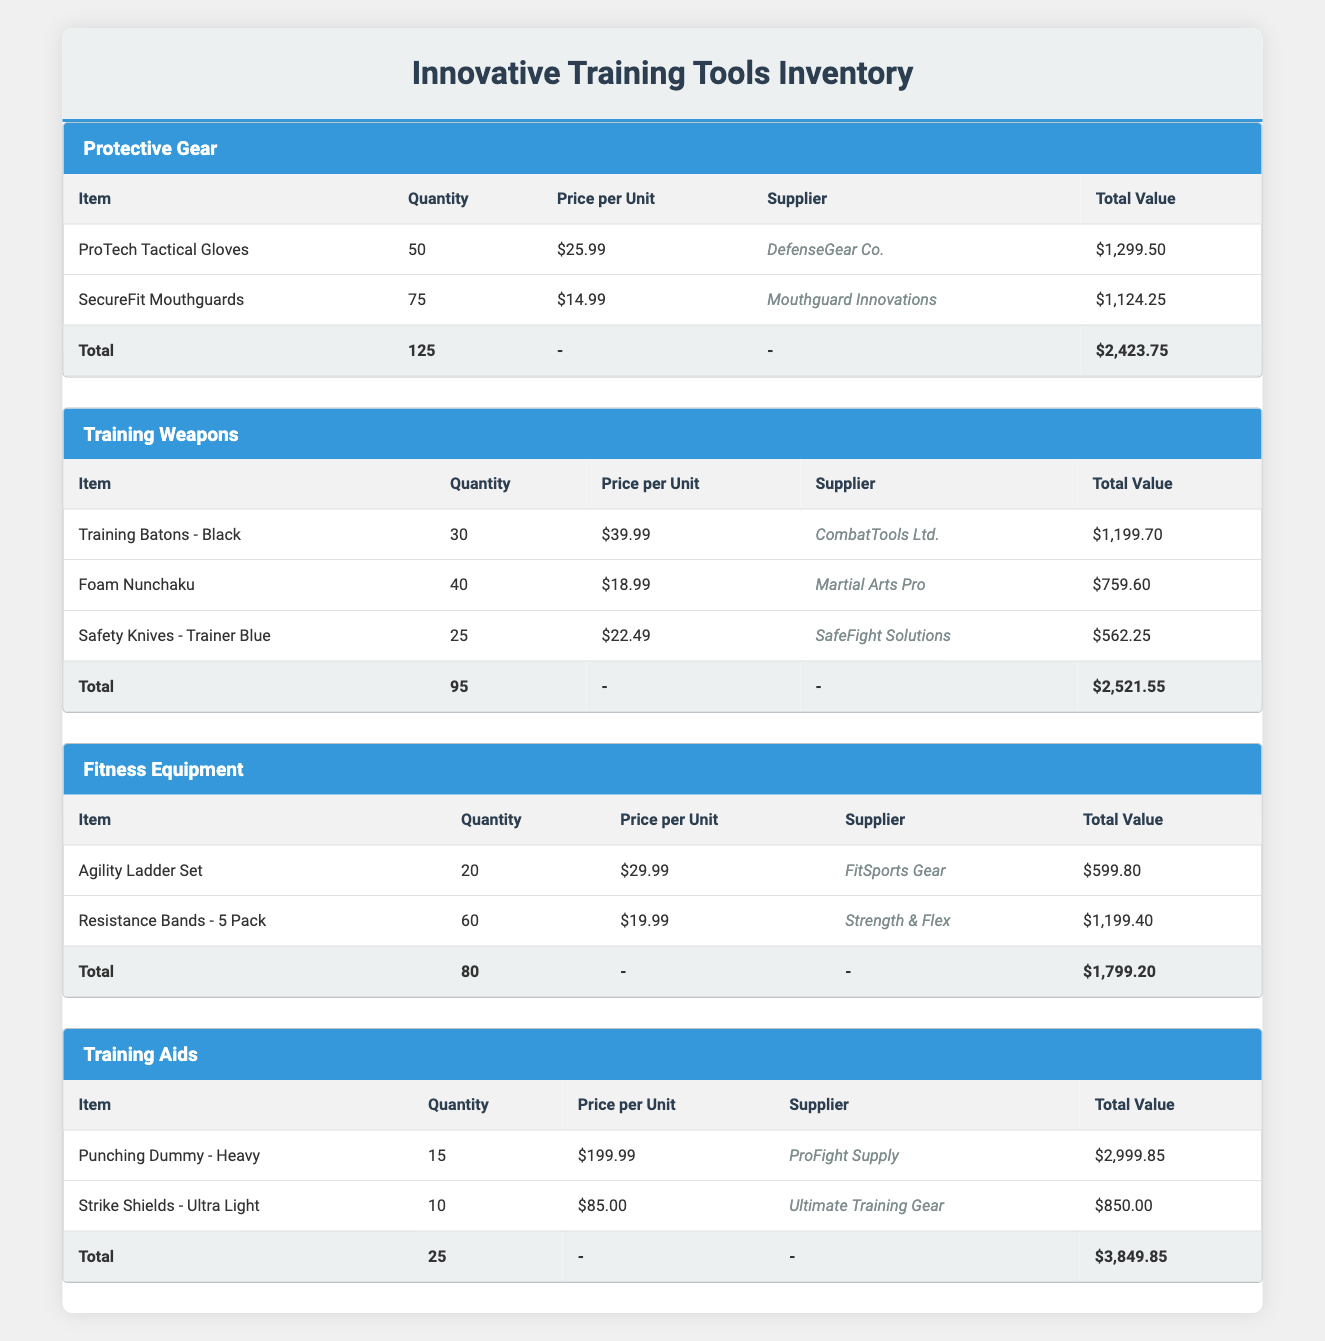What is the total quantity of items in the Protective Gear category? In the Protective Gear category, there are 50 ProTech Tactical Gloves and 75 SecureFit Mouthguards. Adding these together gives us a total quantity of 50 + 75 = 125.
Answer: 125 Which supplier provides the Foam Nunchaku? The Foam Nunchaku is listed under the Training Weapons category, and the supplier for this item is Martial Arts Pro.
Answer: Martial Arts Pro What is the total value of items in the Fitness Equipment category? In the Fitness Equipment category, the Agility Ladder Set is valued at $599.80 and the Resistance Bands - 5 Pack at $1,199.40. Adding these gives us a total of $599.80 + $1,199.40 = $1,799.20.
Answer: $1,799.20 Is the total quantity of Training Weapons greater than that of Fitness Equipment? The total quantity of items in the Training Weapons category is 95 (30 + 40 + 25) and for Fitness Equipment is 80 (20 + 60). Since 95 is greater than 80, the statement is true.
Answer: Yes What is the average price per unit for items in the Training Aids category? The Punching Dummy - Heavy costs $199.99 and the Strike Shields - Ultra Light costs $85.00. To find the average, we first sum the prices: $199.99 + $85.00 = $284.99. Then we divide by the number of items, which is 2, so the average is $284.99 / 2 = $142.495, rounded to $142.50.
Answer: $142.50 How many more SecureFit Mouthguards are there than ProTech Tactical Gloves? The quantity of SecureFit Mouthguards is 75 and the quantity of ProTech Tactical Gloves is 50. The difference is 75 - 50 = 25, meaning there are 25 more Mouthguards.
Answer: 25 What is the total value of Training Aids items combined? The total value of items in the Training Aids category is calculated by adding the values of the Punching Dummy - Heavy at $2,999.85 and the Strike Shields - Ultra Light at $850.00. Thus, $2,999.85 + $850.00 = $3,849.85.
Answer: $3,849.85 Does the supplier DefenseGear Co. provide any items in the Fitness Equipment category? Based on the data, DefenseGear Co. supplies the ProTech Tactical Gloves in the Protective Gear category. There are no items from this supplier listed under Fitness Equipment, hence the statement is false.
Answer: No 